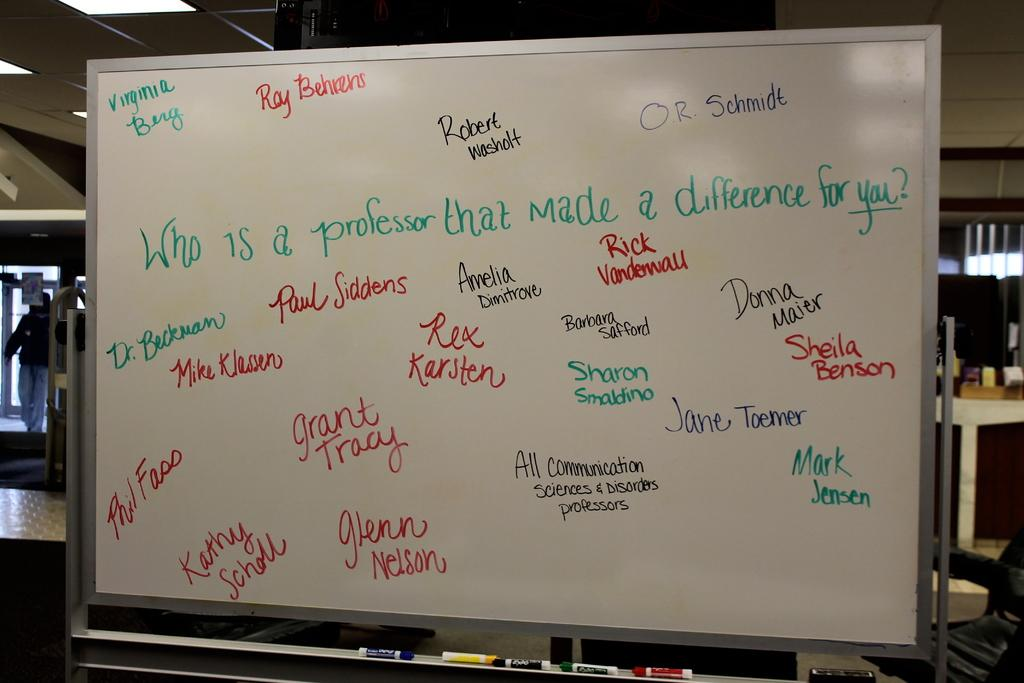<image>
Share a concise interpretation of the image provided. A whiteboard asks who a professor is that made a difference for us. 